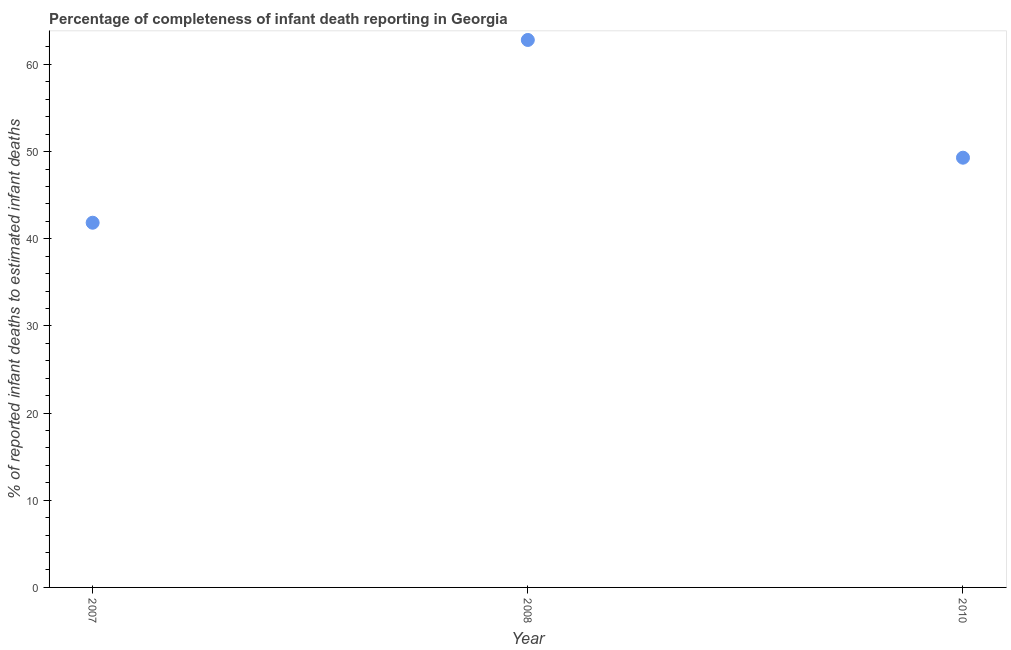What is the completeness of infant death reporting in 2008?
Your answer should be compact. 62.8. Across all years, what is the maximum completeness of infant death reporting?
Give a very brief answer. 62.8. Across all years, what is the minimum completeness of infant death reporting?
Provide a succinct answer. 41.84. In which year was the completeness of infant death reporting maximum?
Your answer should be compact. 2008. What is the sum of the completeness of infant death reporting?
Give a very brief answer. 153.94. What is the difference between the completeness of infant death reporting in 2007 and 2010?
Your answer should be very brief. -7.46. What is the average completeness of infant death reporting per year?
Your response must be concise. 51.31. What is the median completeness of infant death reporting?
Ensure brevity in your answer.  49.3. What is the ratio of the completeness of infant death reporting in 2007 to that in 2008?
Provide a short and direct response. 0.67. What is the difference between the highest and the second highest completeness of infant death reporting?
Make the answer very short. 13.51. What is the difference between the highest and the lowest completeness of infant death reporting?
Your response must be concise. 20.97. In how many years, is the completeness of infant death reporting greater than the average completeness of infant death reporting taken over all years?
Offer a terse response. 1. Does the graph contain grids?
Your answer should be compact. No. What is the title of the graph?
Ensure brevity in your answer.  Percentage of completeness of infant death reporting in Georgia. What is the label or title of the Y-axis?
Keep it short and to the point. % of reported infant deaths to estimated infant deaths. What is the % of reported infant deaths to estimated infant deaths in 2007?
Provide a short and direct response. 41.84. What is the % of reported infant deaths to estimated infant deaths in 2008?
Give a very brief answer. 62.8. What is the % of reported infant deaths to estimated infant deaths in 2010?
Your response must be concise. 49.3. What is the difference between the % of reported infant deaths to estimated infant deaths in 2007 and 2008?
Offer a very short reply. -20.97. What is the difference between the % of reported infant deaths to estimated infant deaths in 2007 and 2010?
Your response must be concise. -7.46. What is the difference between the % of reported infant deaths to estimated infant deaths in 2008 and 2010?
Offer a terse response. 13.51. What is the ratio of the % of reported infant deaths to estimated infant deaths in 2007 to that in 2008?
Give a very brief answer. 0.67. What is the ratio of the % of reported infant deaths to estimated infant deaths in 2007 to that in 2010?
Provide a short and direct response. 0.85. What is the ratio of the % of reported infant deaths to estimated infant deaths in 2008 to that in 2010?
Provide a short and direct response. 1.27. 